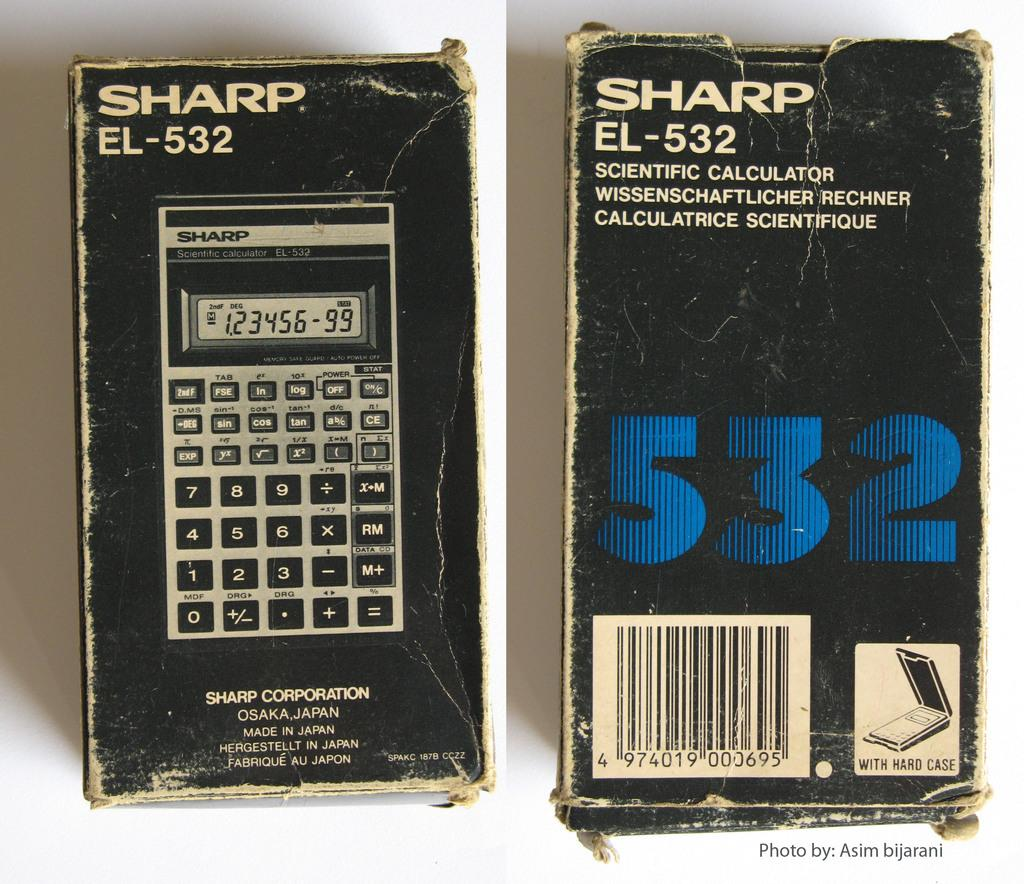Provide a one-sentence caption for the provided image. Sharp EL-532 is the model number shown on this calculator box. 